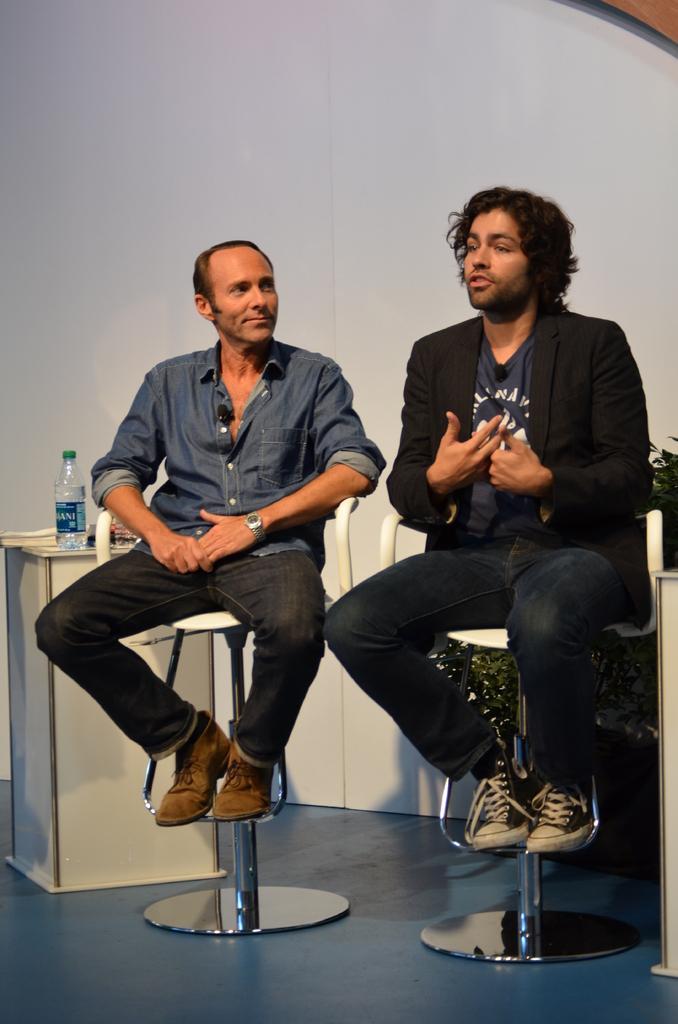Describe this image in one or two sentences. In the image we can see there are two men who are sitting on chair. 